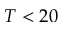Convert formula to latex. <formula><loc_0><loc_0><loc_500><loc_500>T < 2 0</formula> 